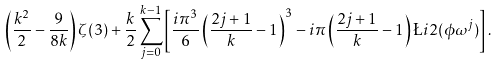Convert formula to latex. <formula><loc_0><loc_0><loc_500><loc_500>\left ( \frac { k ^ { 2 } } { 2 } - \frac { 9 } { 8 k } \right ) \zeta ( 3 ) + \frac { k } { 2 } \sum _ { j = 0 } ^ { k - 1 } \left [ \frac { i \pi ^ { 3 } } { 6 } \left ( \frac { 2 j + 1 } { k } - 1 \right ) ^ { 3 } - i \pi \left ( \frac { 2 j + 1 } { k } - 1 \right ) \L i { 2 } ( \phi \omega ^ { j } ) \right ] .</formula> 